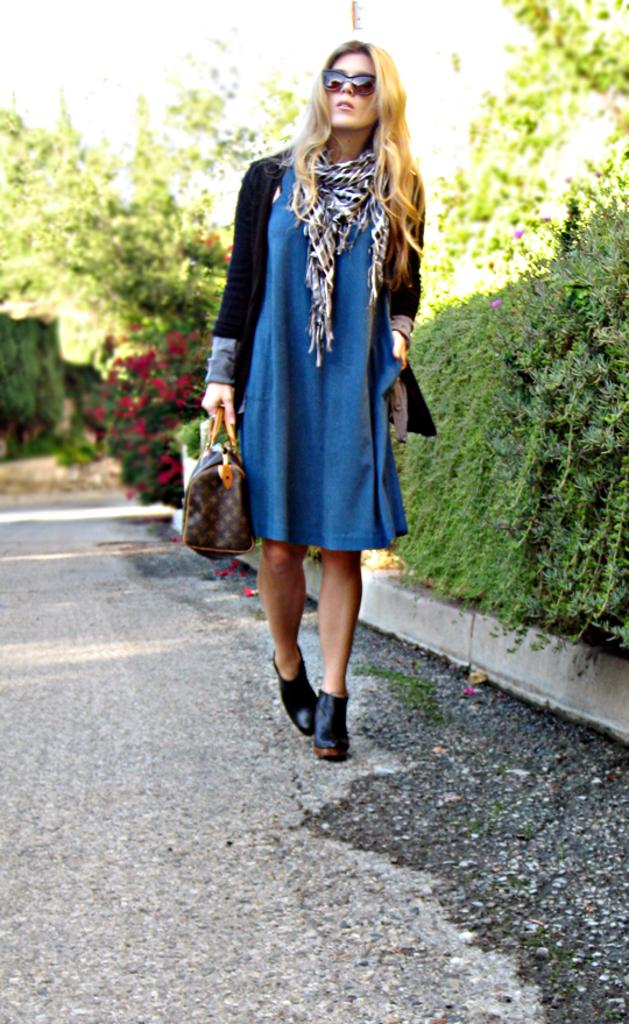Who is present in the image? There is a woman in the image. What is the woman doing? The woman is walking. What is the woman holding in the image? The woman is holding a bag. What accessory is the woman wearing? The woman is wearing glasses (specs). What can be seen on the right side of the image? There are green color plants and trees on the right side of the image. What is the woman walking on? There is a path in the image. What type of veil can be seen on the woman's head in the image? There is no veil present on the woman's head in the image; she is wearing glasses (specs). What type of quill is the woman using to write on the path in the image? There is no quill or writing activity depicted in the image; the woman is simply walking on the path. 